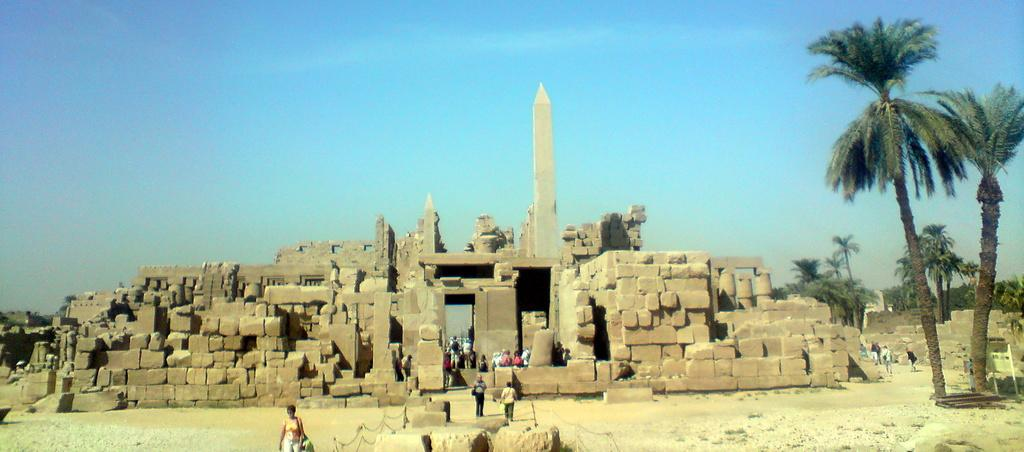What type of location is shown in the image? The image depicts a tourist place. What material was used to construct the buildings in the image? The construction in the image was built with stones. Are there any people present in the image? Yes, there are people in the image. What type of vegetation can be seen in the image? There are trees in the image. What is visible in the background of the image? The sky is visible in the background of the image. What type of corn can be seen growing in the image? There is no corn visible in the image; it depicts a tourist place with stone construction, people, trees, and a visible sky. What scent is associated with the pancake in the image? There is no pancake present in the image, so it is not possible to determine any associated scent. 